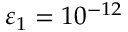<formula> <loc_0><loc_0><loc_500><loc_500>\varepsilon _ { 1 } = 1 0 ^ { - 1 2 }</formula> 